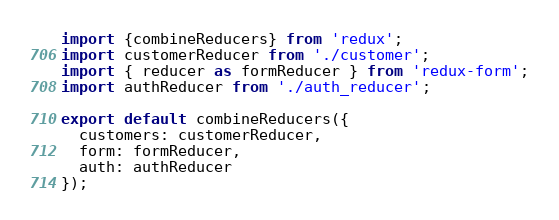Convert code to text. <code><loc_0><loc_0><loc_500><loc_500><_JavaScript_>import {combineReducers} from 'redux';
import customerReducer from './customer';
import { reducer as formReducer } from 'redux-form';
import authReducer from './auth_reducer';

export default combineReducers({
  customers: customerReducer,
  form: formReducer,
  auth: authReducer
});
</code> 